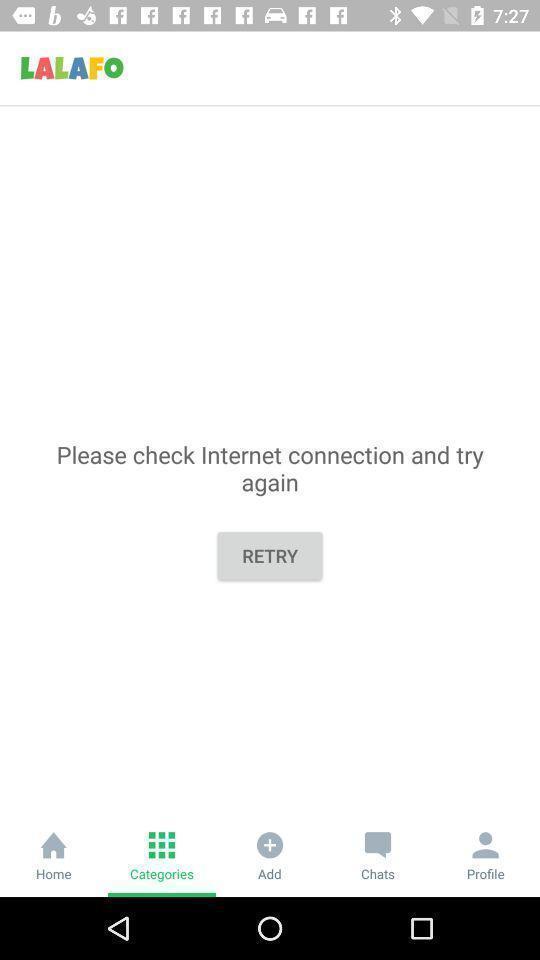Provide a textual representation of this image. Retry page ication. 